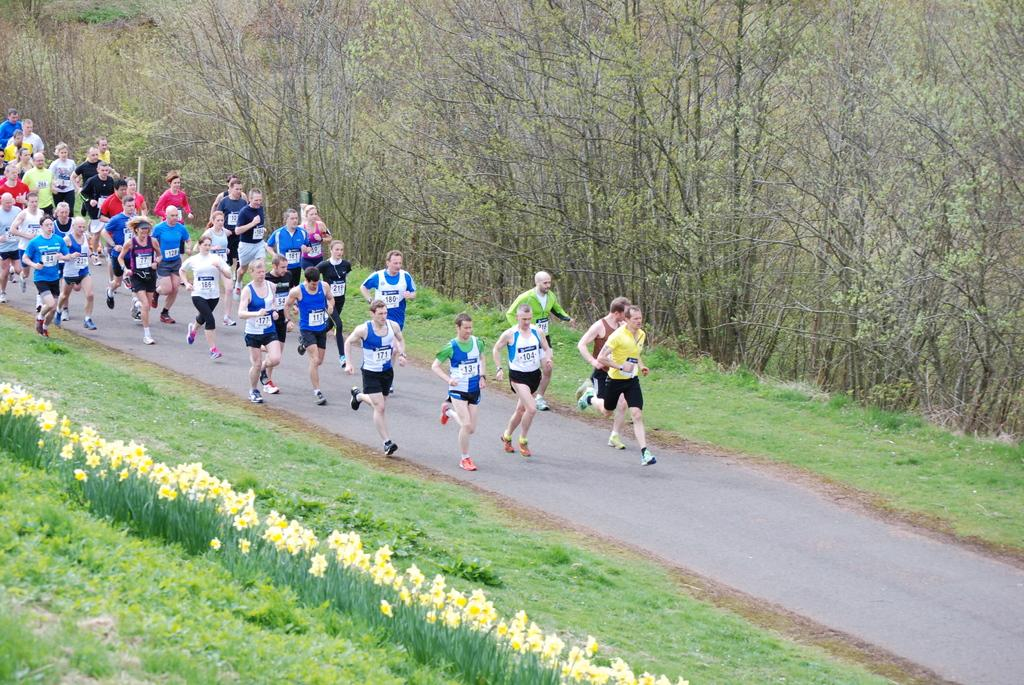What are the people in the image doing? The people in the image are running on the road. What type of surface are the people running on? The people are running on the road. What can be seen growing in the image? There is grass, plants with flowers, and trees in the image. What is the background of the image? The background of the image includes trees. What type of dress is the person wearing while swimming in the image? There is no person swimming in the image, and no dress is visible. What is the person carrying in the sack while running in the image? There is no person carrying a sack in the image. 